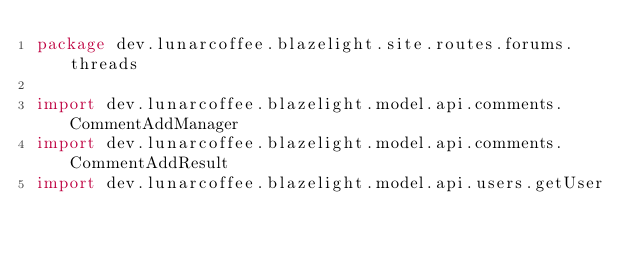Convert code to text. <code><loc_0><loc_0><loc_500><loc_500><_Kotlin_>package dev.lunarcoffee.blazelight.site.routes.forums.threads

import dev.lunarcoffee.blazelight.model.api.comments.CommentAddManager
import dev.lunarcoffee.blazelight.model.api.comments.CommentAddResult
import dev.lunarcoffee.blazelight.model.api.users.getUser</code> 